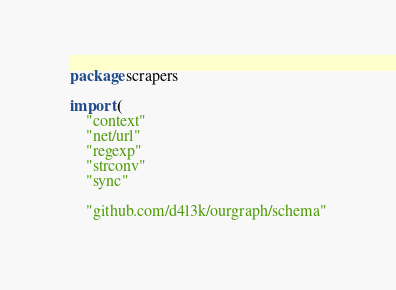<code> <loc_0><loc_0><loc_500><loc_500><_Go_>package scrapers

import (
	"context"
	"net/url"
	"regexp"
	"strconv"
	"sync"

	"github.com/d4l3k/ourgraph/schema"</code> 